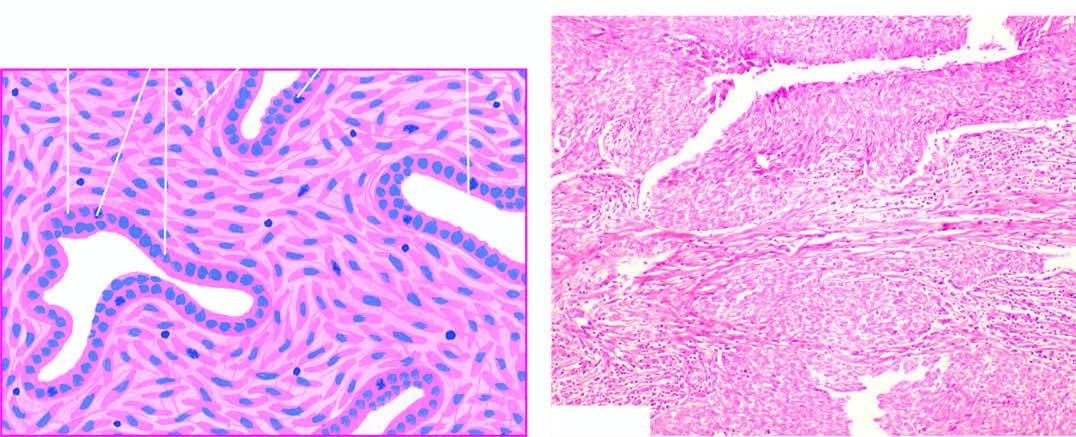what did spindle cell areas form?
Answer the question using a single word or phrase. Fibrosarcoma-like growth pattern 